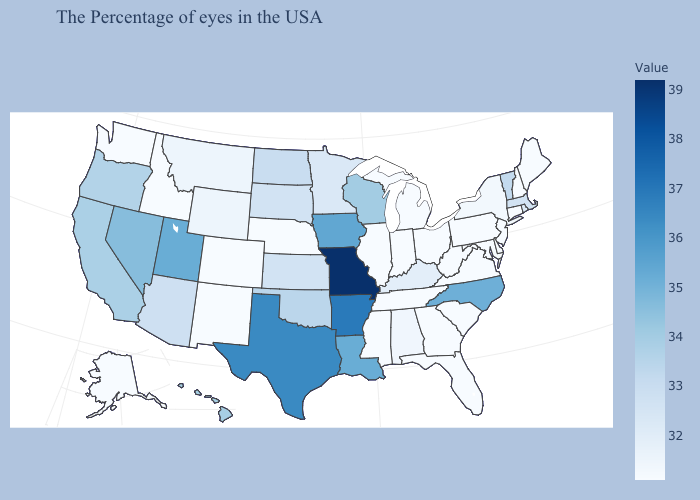Does the map have missing data?
Write a very short answer. No. Does Connecticut have the lowest value in the USA?
Answer briefly. Yes. Which states have the lowest value in the Northeast?
Be succinct. Maine, New Hampshire, Connecticut, New Jersey, Pennsylvania. Does Missouri have the highest value in the USA?
Be succinct. Yes. Does Alabama have a higher value than Wisconsin?
Be succinct. No. 